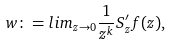<formula> <loc_0><loc_0><loc_500><loc_500>w \colon = l i m _ { z \to 0 } \frac { 1 } { z ^ { k } } S _ { z } ^ { \prime } f ( z ) ,</formula> 